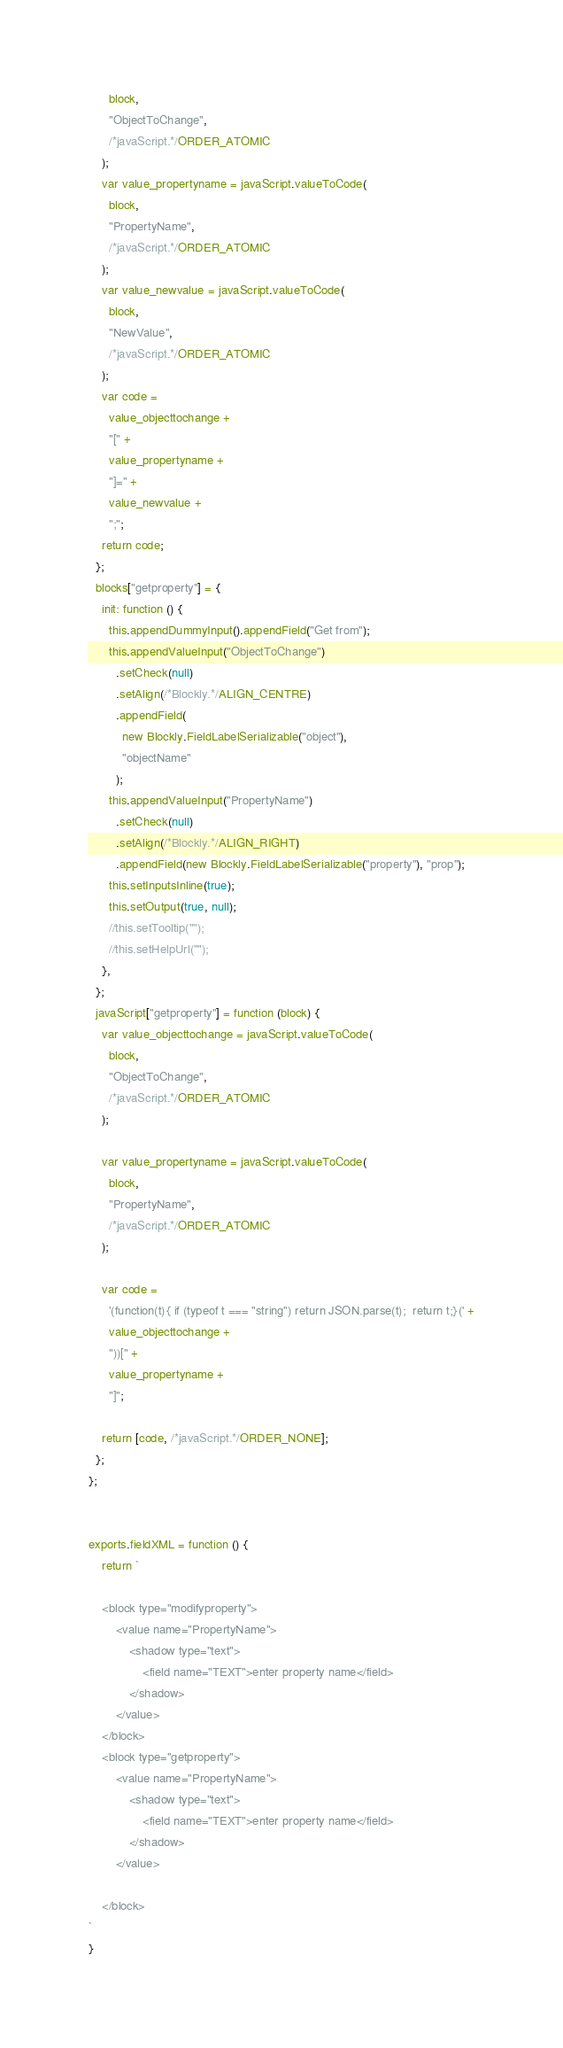Convert code to text. <code><loc_0><loc_0><loc_500><loc_500><_JavaScript_>      block,
      "ObjectToChange",
      /*javaScript.*/ORDER_ATOMIC
    );
    var value_propertyname = javaScript.valueToCode(
      block,
      "PropertyName",
      /*javaScript.*/ORDER_ATOMIC
    );
    var value_newvalue = javaScript.valueToCode(
      block,
      "NewValue",
      /*javaScript.*/ORDER_ATOMIC
    );
    var code =
      value_objecttochange +
      "[" +
      value_propertyname +
      "]=" +
      value_newvalue +
      ";";
    return code;
  };
  blocks["getproperty"] = {
    init: function () {
      this.appendDummyInput().appendField("Get from");
      this.appendValueInput("ObjectToChange")
        .setCheck(null)
        .setAlign(/*Blockly.*/ALIGN_CENTRE)
        .appendField(
          new Blockly.FieldLabelSerializable("object"),
          "objectName"
        );
      this.appendValueInput("PropertyName")
        .setCheck(null)
        .setAlign(/*Blockly.*/ALIGN_RIGHT)
        .appendField(new Blockly.FieldLabelSerializable("property"), "prop");
      this.setInputsInline(true);
      this.setOutput(true, null);
      //this.setTooltip("");
      //this.setHelpUrl("");
    },
  };
  javaScript["getproperty"] = function (block) {
    var value_objecttochange = javaScript.valueToCode(
      block,
      "ObjectToChange",
      /*javaScript.*/ORDER_ATOMIC
    );

    var value_propertyname = javaScript.valueToCode(
      block,
      "PropertyName",
      /*javaScript.*/ORDER_ATOMIC
    );

    var code =
      '(function(t){ if (typeof t === "string") return JSON.parse(t);  return t;}(' +
      value_objecttochange +
      "))[" +
      value_propertyname +
      "]";

    return [code, /*javaScript.*/ORDER_NONE];
  };
};


exports.fieldXML = function () {
    return `
    
    <block type="modifyproperty">
        <value name="PropertyName">
            <shadow type="text">
                <field name="TEXT">enter property name</field>
            </shadow>
        </value>
    </block>
    <block type="getproperty">
        <value name="PropertyName">
            <shadow type="text">
                <field name="TEXT">enter property name</field>
            </shadow>
        </value>

    </block>    
`
}</code> 